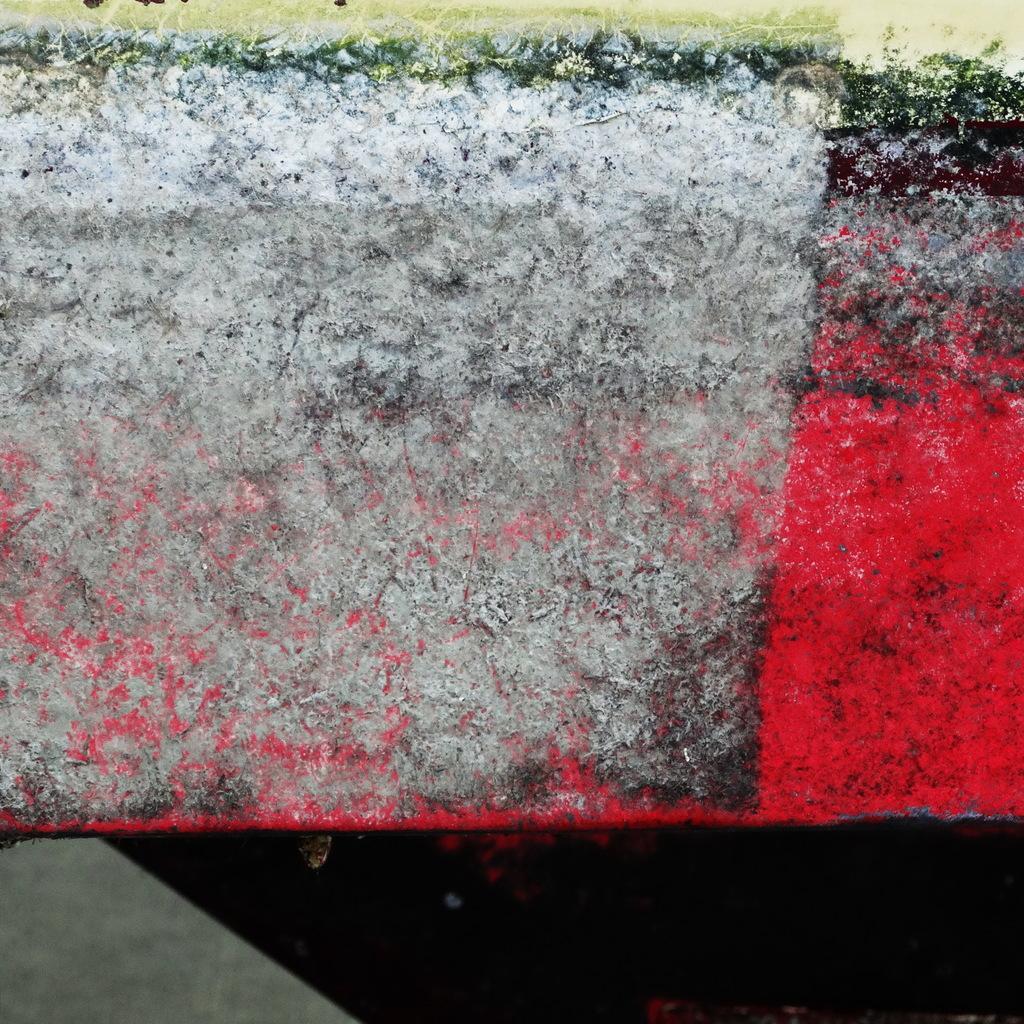Can you describe this image briefly? We can see colorful wall and above the wall we can see grass. 